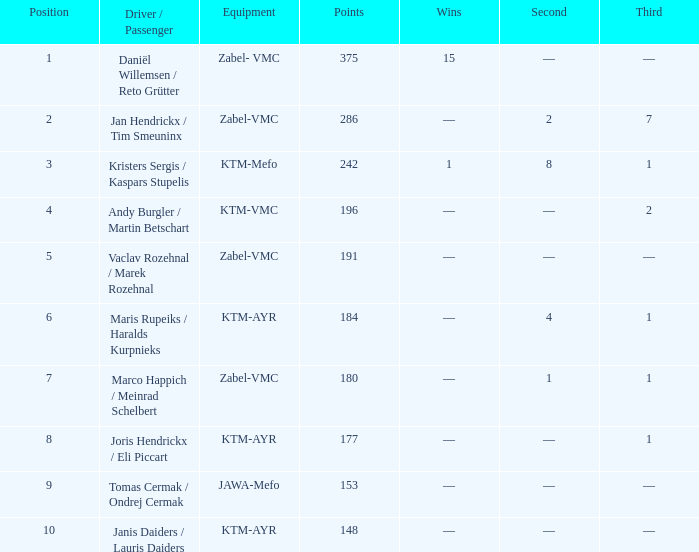What was the peak points when the second was 4? 184.0. 